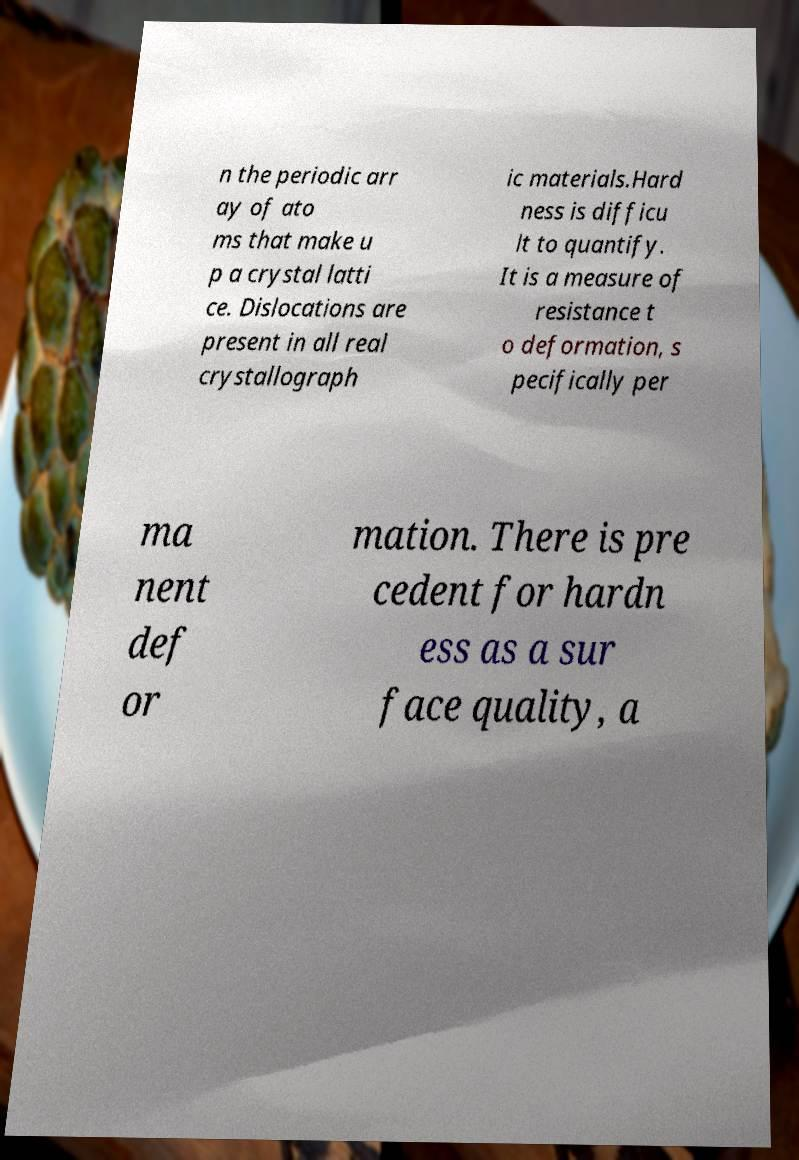Please identify and transcribe the text found in this image. n the periodic arr ay of ato ms that make u p a crystal latti ce. Dislocations are present in all real crystallograph ic materials.Hard ness is difficu lt to quantify. It is a measure of resistance t o deformation, s pecifically per ma nent def or mation. There is pre cedent for hardn ess as a sur face quality, a 